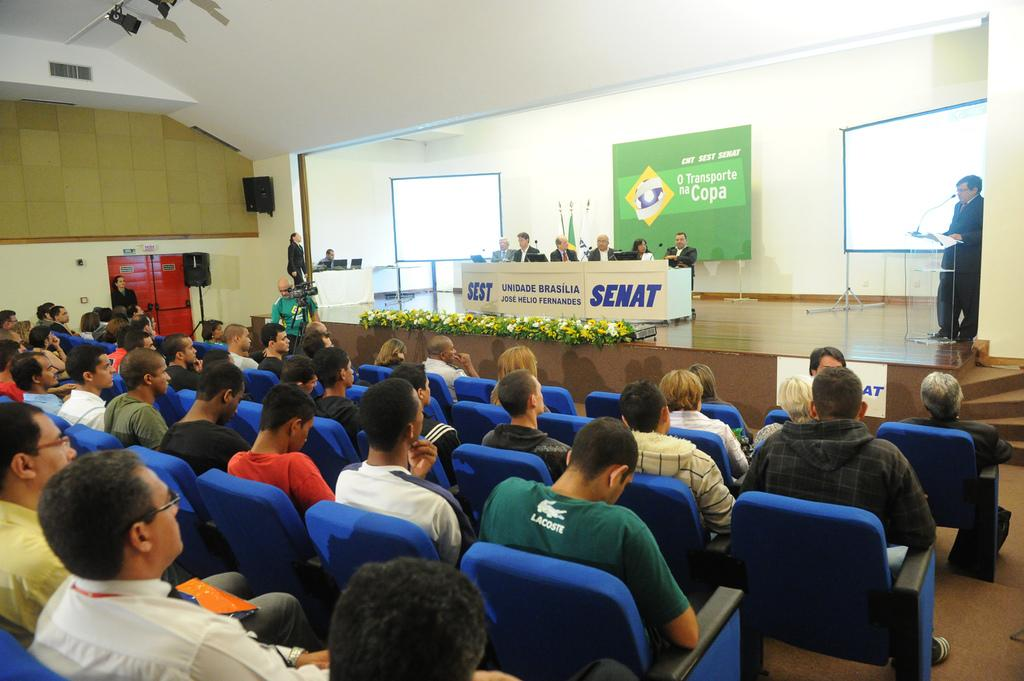What is happening on the left side of the image? There is a group of people sitting on chairs on the left side of the image. What is happening in the middle of the image? There are people sitting on a stage in the middle of the image. What is happening on the right side of the image? A person is standing and talking into a microphone on the right side of the image. What type of underwear is the person on the stage wearing in the image? There is no information about the underwear of any person in the image. Can you tell me how many cows are present on the stage in the image? There are no cows present in the image; it features people sitting on a stage. 